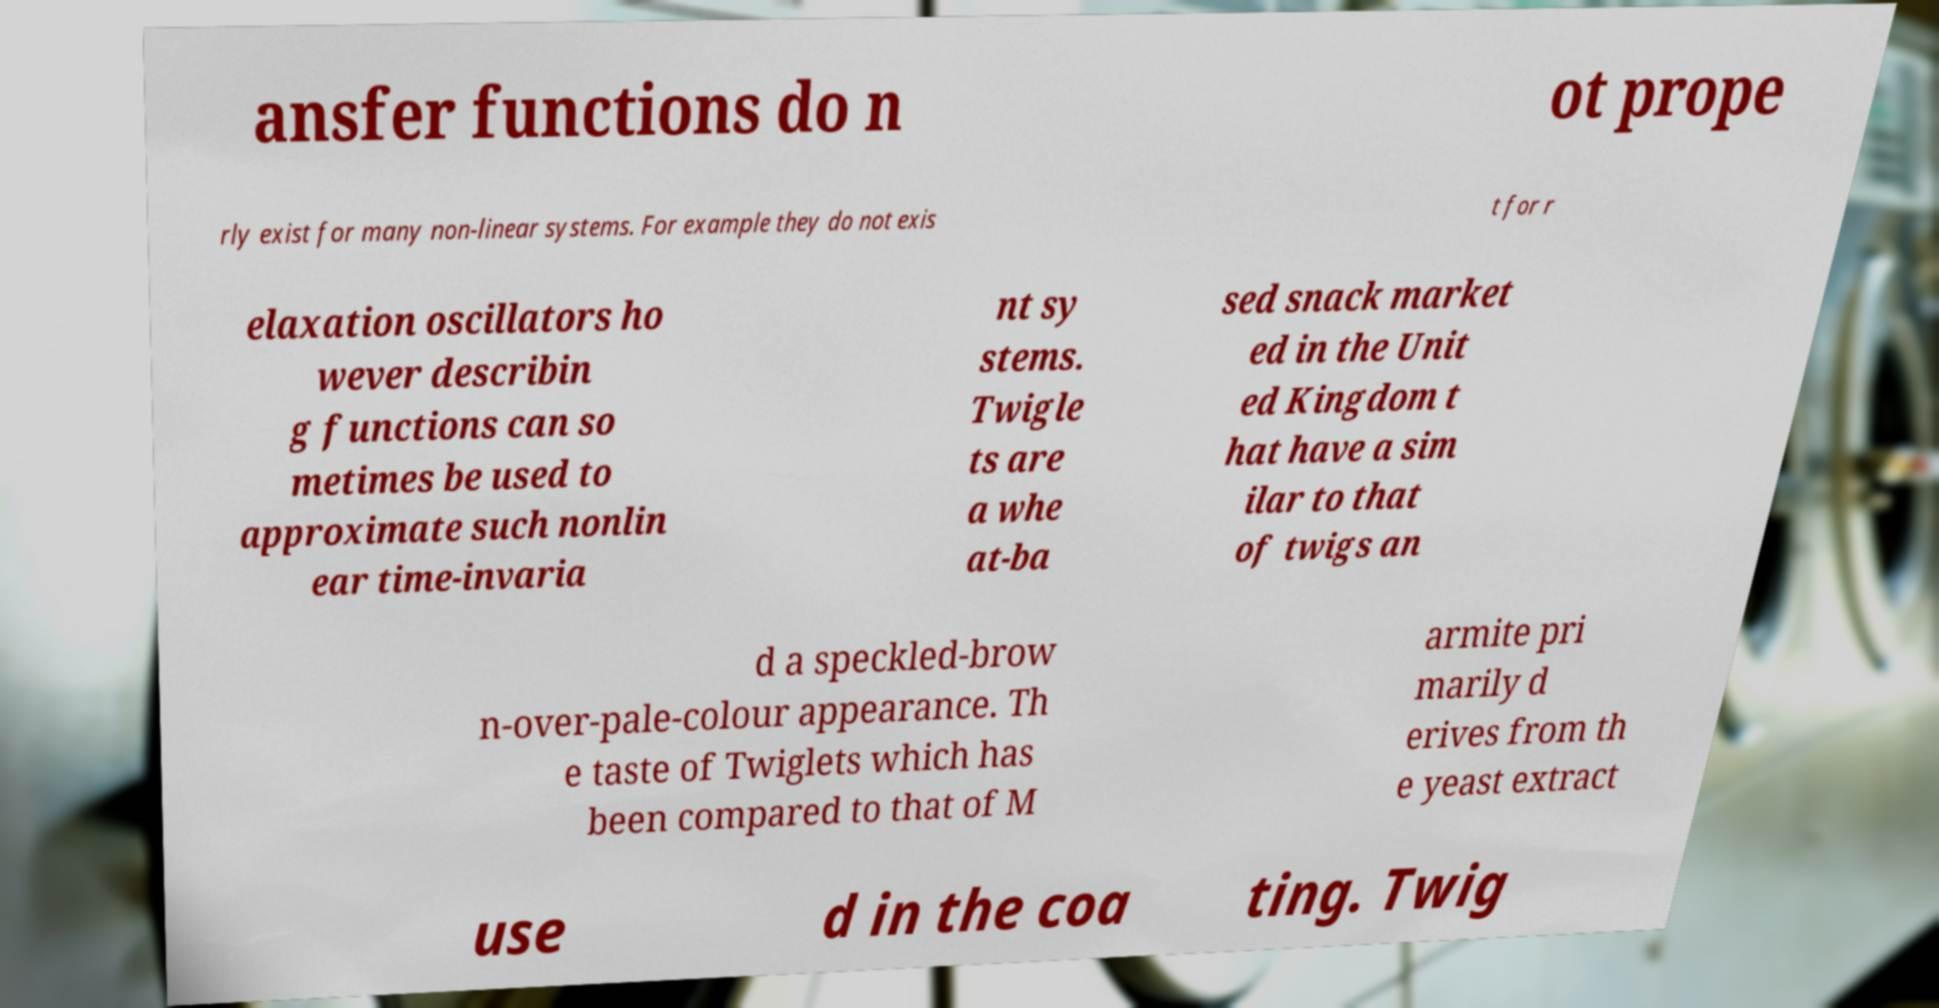Please read and relay the text visible in this image. What does it say? ansfer functions do n ot prope rly exist for many non-linear systems. For example they do not exis t for r elaxation oscillators ho wever describin g functions can so metimes be used to approximate such nonlin ear time-invaria nt sy stems. Twigle ts are a whe at-ba sed snack market ed in the Unit ed Kingdom t hat have a sim ilar to that of twigs an d a speckled-brow n-over-pale-colour appearance. Th e taste of Twiglets which has been compared to that of M armite pri marily d erives from th e yeast extract use d in the coa ting. Twig 